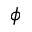<formula> <loc_0><loc_0><loc_500><loc_500>\phi</formula> 